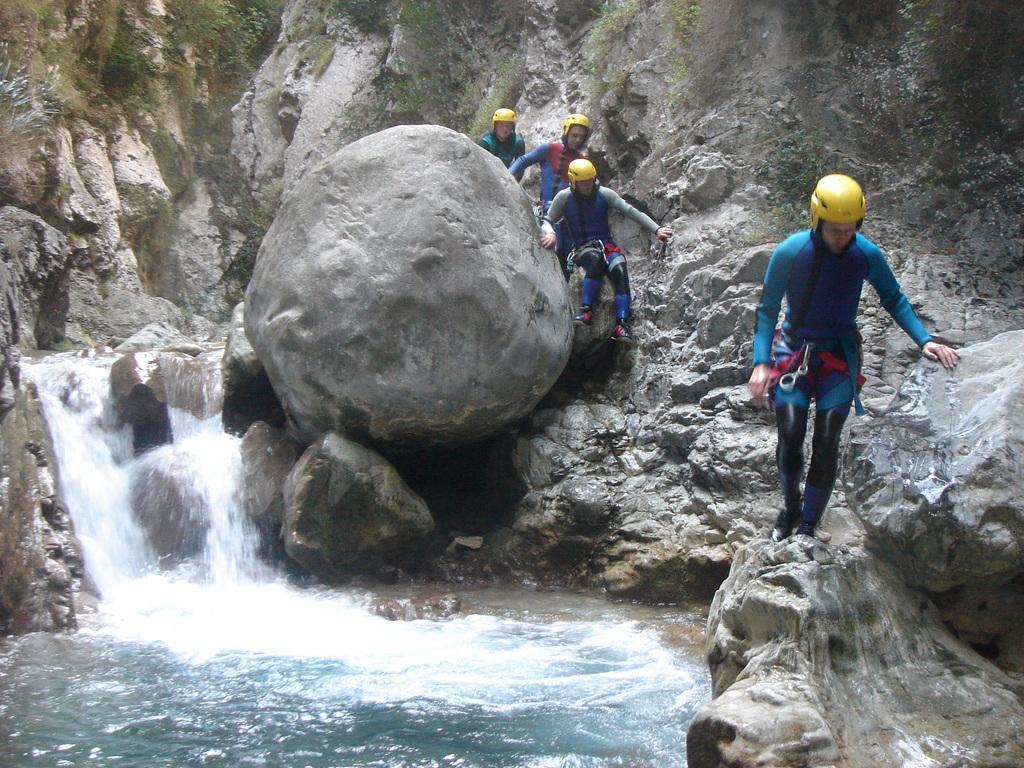Please provide a concise description of this image. In this picture, we see four people are canyoning. Beside them, we see the rocks. At the bottom, we see the water and the waterfalls. In the right top, we see the trees. 